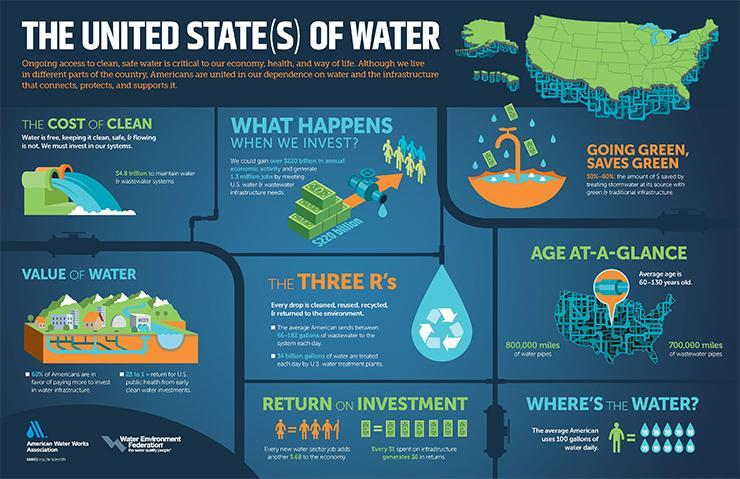expand the three R's
Answer the question with a short phrase. reused, recycled and returned what is the length of water pipes 800,000 miles 